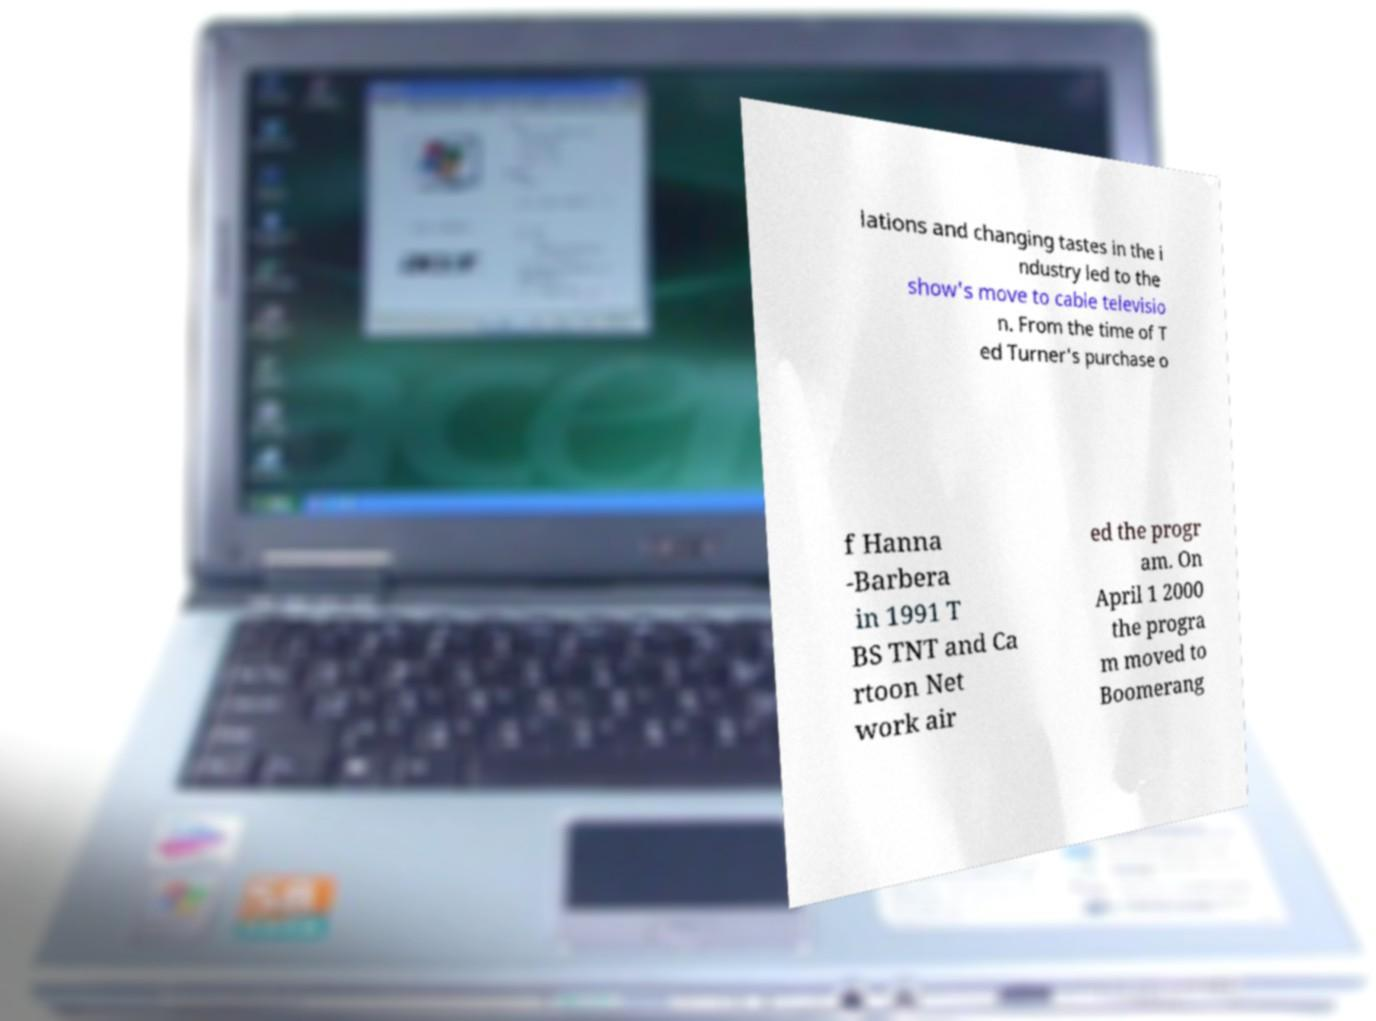Could you assist in decoding the text presented in this image and type it out clearly? lations and changing tastes in the i ndustry led to the show's move to cable televisio n. From the time of T ed Turner's purchase o f Hanna -Barbera in 1991 T BS TNT and Ca rtoon Net work air ed the progr am. On April 1 2000 the progra m moved to Boomerang 